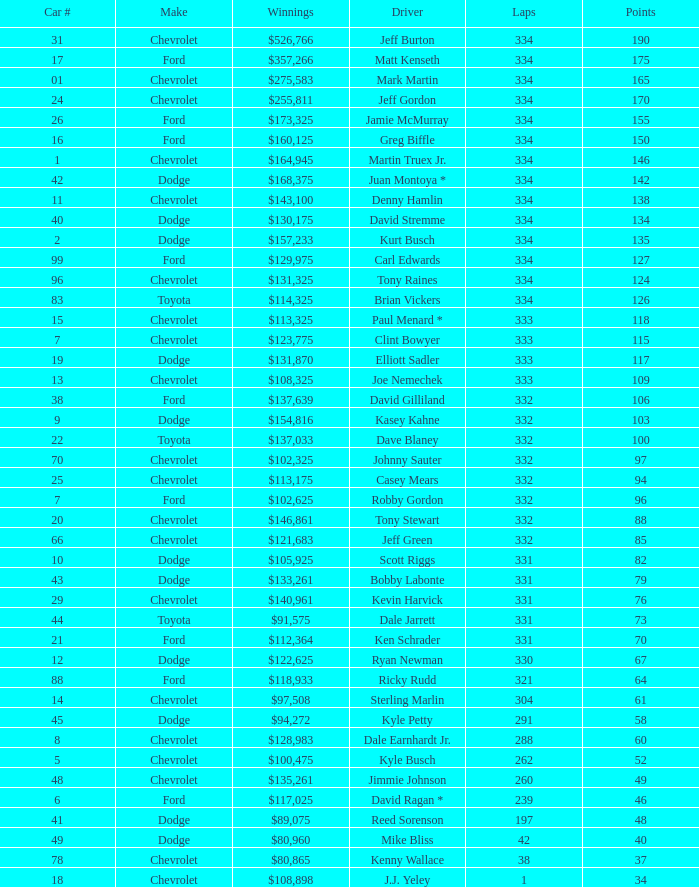How many total laps did the Chevrolet that won $97,508 make? 1.0. 